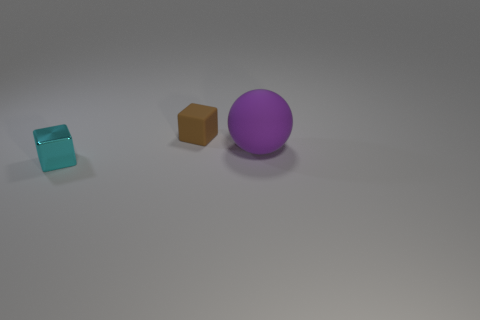Add 1 cyan metallic cubes. How many objects exist? 4 Subtract all spheres. How many objects are left? 2 Add 1 small cyan shiny blocks. How many small cyan shiny blocks are left? 2 Add 3 brown blocks. How many brown blocks exist? 4 Subtract 0 red cylinders. How many objects are left? 3 Subtract all blue metal spheres. Subtract all matte objects. How many objects are left? 1 